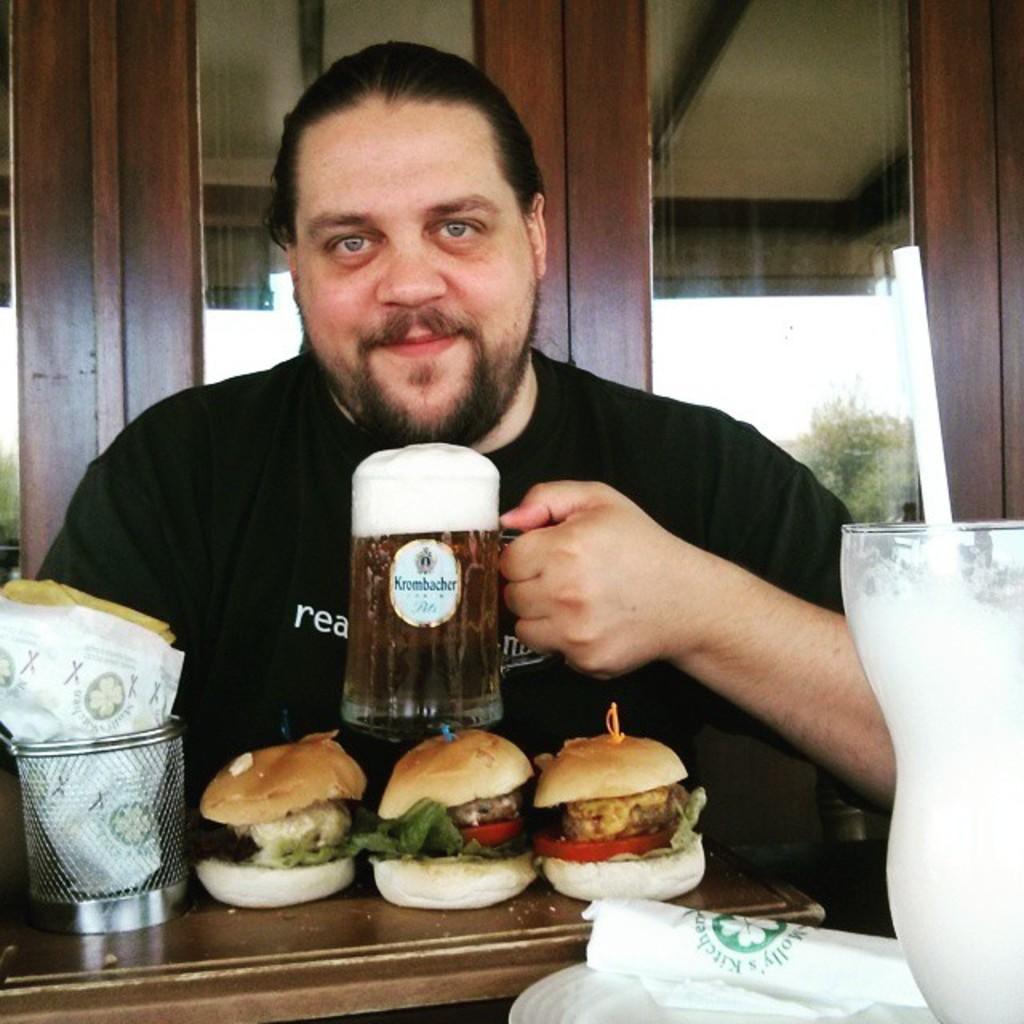In one or two sentences, can you explain what this image depicts? In this picture there is a man sitting besides a table. He is wearing a black t shirt and holding a glass. On the table there are burgers and a jar. Towards the right there is a glass with some juice. In the background there is a window. 